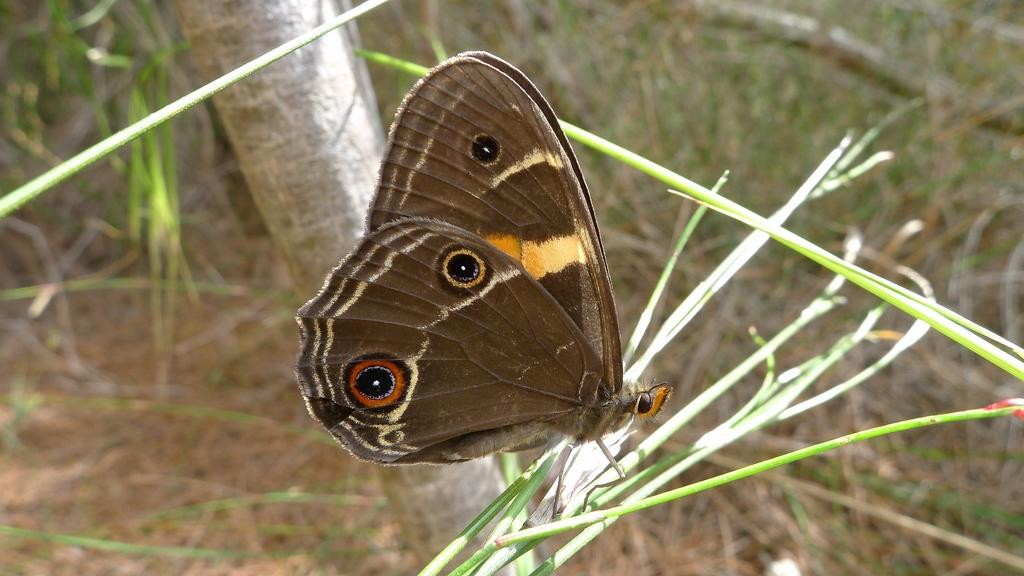What type of insect is present in the image? There is a butterfly in the image. What color is the butterfly? The butterfly is brown in color. What type of environment is depicted in the image? The image appears to depict grass. What can be seen in the background of the image? There is a tree trunk visible in the background of the image. What type of jeans is the butterfly wearing in the image? Butterflies do not wear jeans, as they are insects and do not have the ability to wear clothing. 